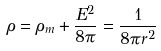<formula> <loc_0><loc_0><loc_500><loc_500>\rho = \rho _ { m } + \frac { E ^ { 2 } } { 8 \pi } = \frac { 1 } { 8 \pi r ^ { 2 } }</formula> 